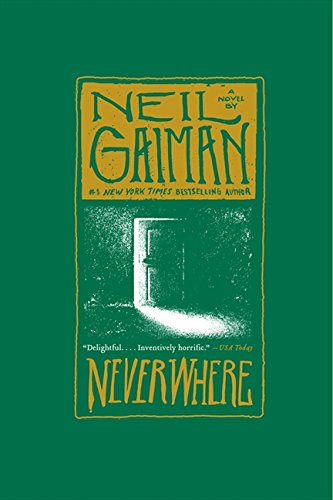What is the genre of this book? The genre of 'Neverwhere: A Novel' is Science Fiction & Fantasy, aptly fitting as it delves into surreal, imaginative realms that challenge our perception of the everyday world. 